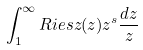Convert formula to latex. <formula><loc_0><loc_0><loc_500><loc_500>\int _ { 1 } ^ { \infty } R i e s z ( z ) z ^ { s } \frac { d z } { z }</formula> 